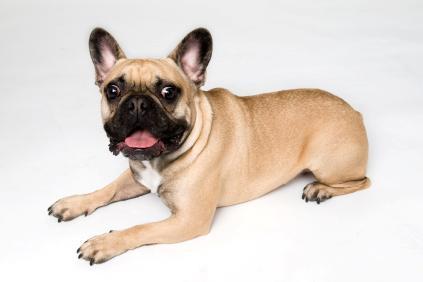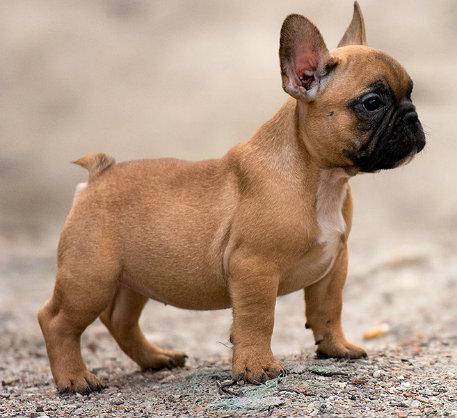The first image is the image on the left, the second image is the image on the right. Analyze the images presented: Is the assertion "One dog is standing and one is lying down, neither wearing a collar." valid? Answer yes or no. Yes. The first image is the image on the left, the second image is the image on the right. Given the left and right images, does the statement "An image shows one puppy standing outdoors, in profile, turned rightward." hold true? Answer yes or no. Yes. 